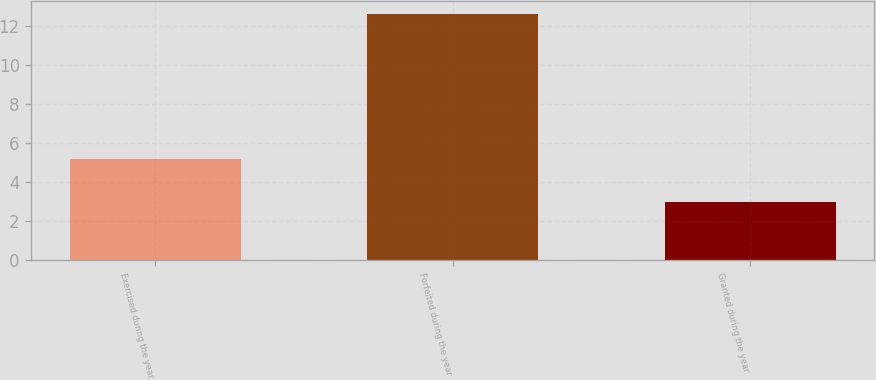Convert chart. <chart><loc_0><loc_0><loc_500><loc_500><bar_chart><fcel>Exercised during the year<fcel>Forfeited during the year<fcel>Granted during the year<nl><fcel>5.18<fcel>12.61<fcel>2.97<nl></chart> 